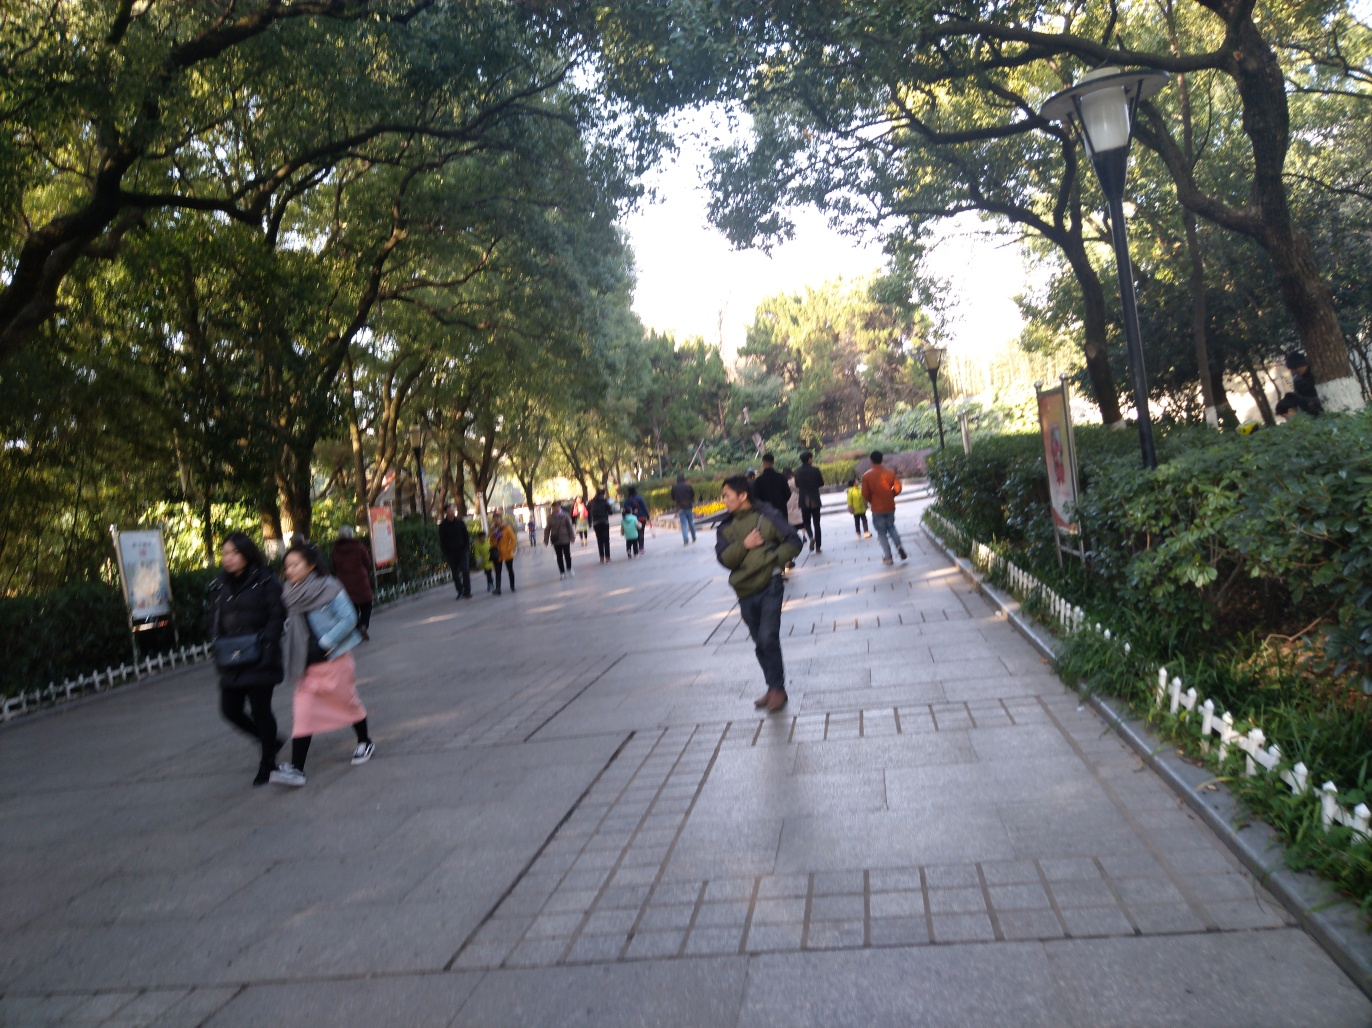Can you describe the environment depicted in this image? The image captures an outdoor scene possibly in a park or urban green space. There are numerous trees providing ample shade, and the pathway seems to be paved with large tiles or stones. Pedestrians are scattered throughout, suggesting a public and possibly leisurely space. The image conveys a sense of daily life, with people possibly enjoying a casual stroll or commute. 